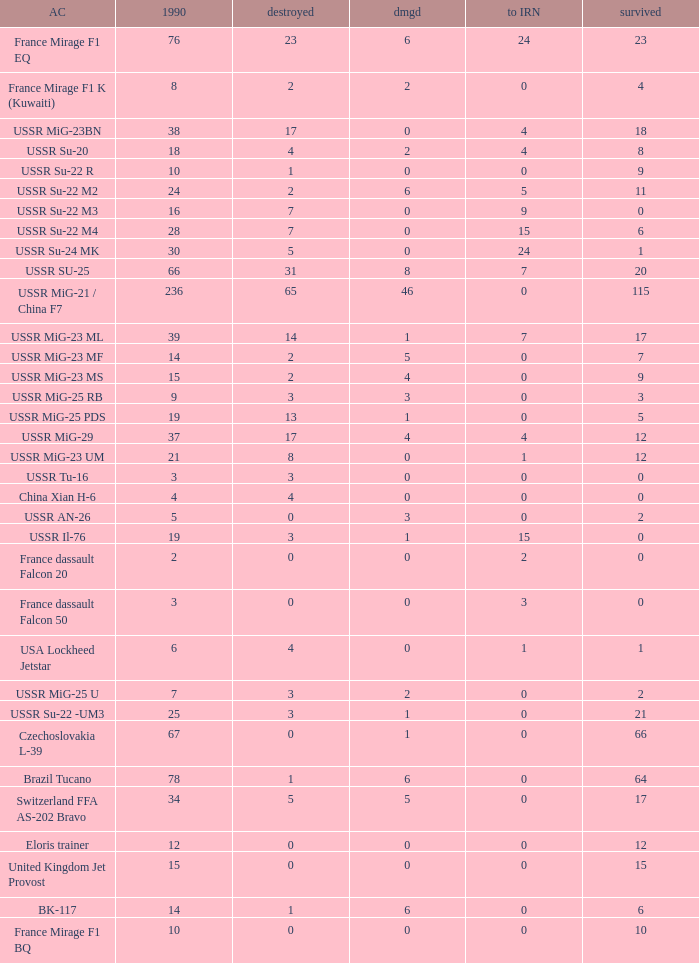If there were 14 in 1990 and 6 survived how many were destroyed? 1.0. 